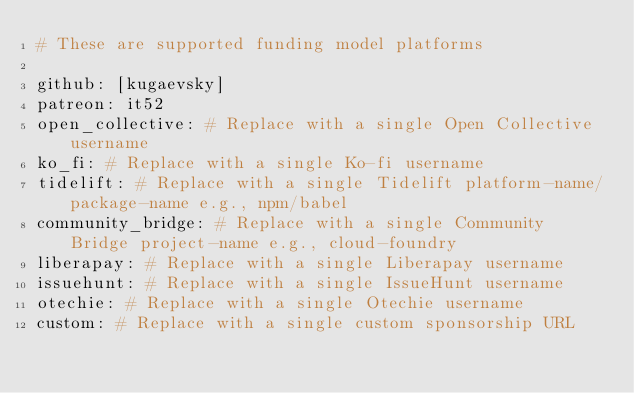Convert code to text. <code><loc_0><loc_0><loc_500><loc_500><_YAML_># These are supported funding model platforms

github: [kugaevsky]
patreon: it52
open_collective: # Replace with a single Open Collective username
ko_fi: # Replace with a single Ko-fi username
tidelift: # Replace with a single Tidelift platform-name/package-name e.g., npm/babel
community_bridge: # Replace with a single Community Bridge project-name e.g., cloud-foundry
liberapay: # Replace with a single Liberapay username
issuehunt: # Replace with a single IssueHunt username
otechie: # Replace with a single Otechie username
custom: # Replace with a single custom sponsorship URL
</code> 